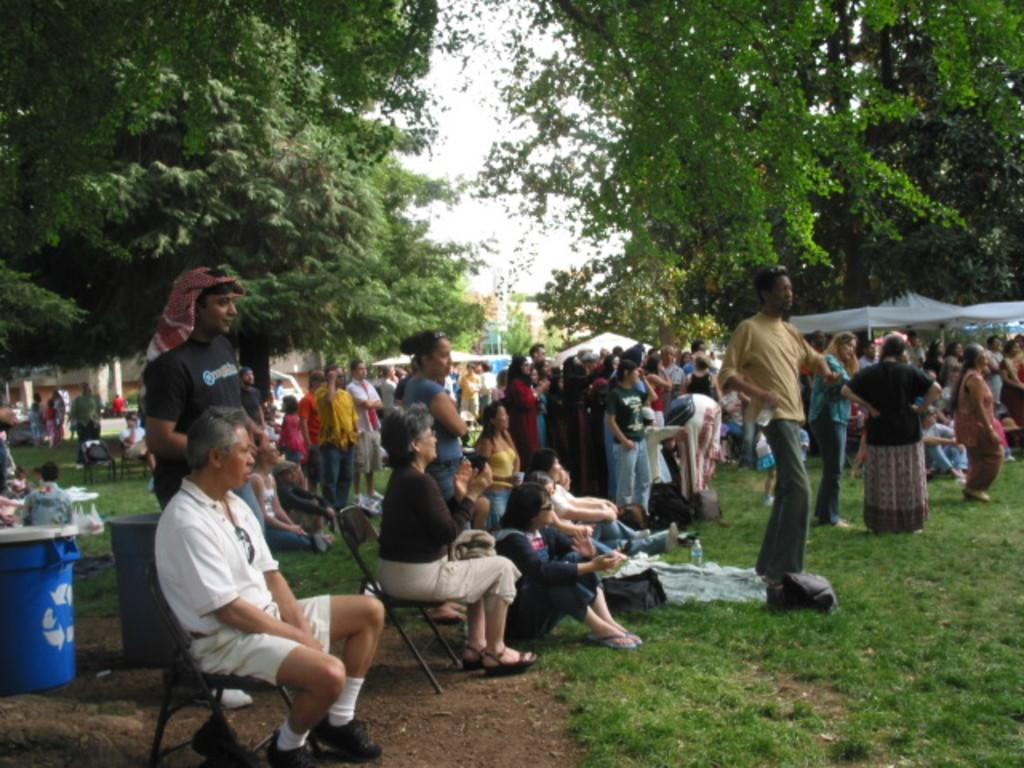What type of vegetation is present in the image? There is grass in the image. Who or what can be seen in the image? There are people in the image. What is the landscape feature on both sides of the image? There are trees on both the left and right sides of the image. What is visible at the top of the image? The sky is visible at the top of the image. What type of pollution can be seen in the image? There is no pollution visible in the image. Is there a tent present in the image? There is no tent present in the image. 